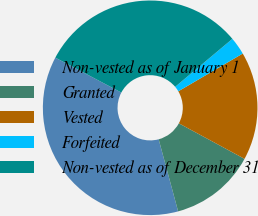Convert chart. <chart><loc_0><loc_0><loc_500><loc_500><pie_chart><fcel>Non-vested as of January 1<fcel>Granted<fcel>Vested<fcel>Forfeited<fcel>Non-vested as of December 31<nl><fcel>36.94%<fcel>12.91%<fcel>16.33%<fcel>2.67%<fcel>31.15%<nl></chart> 